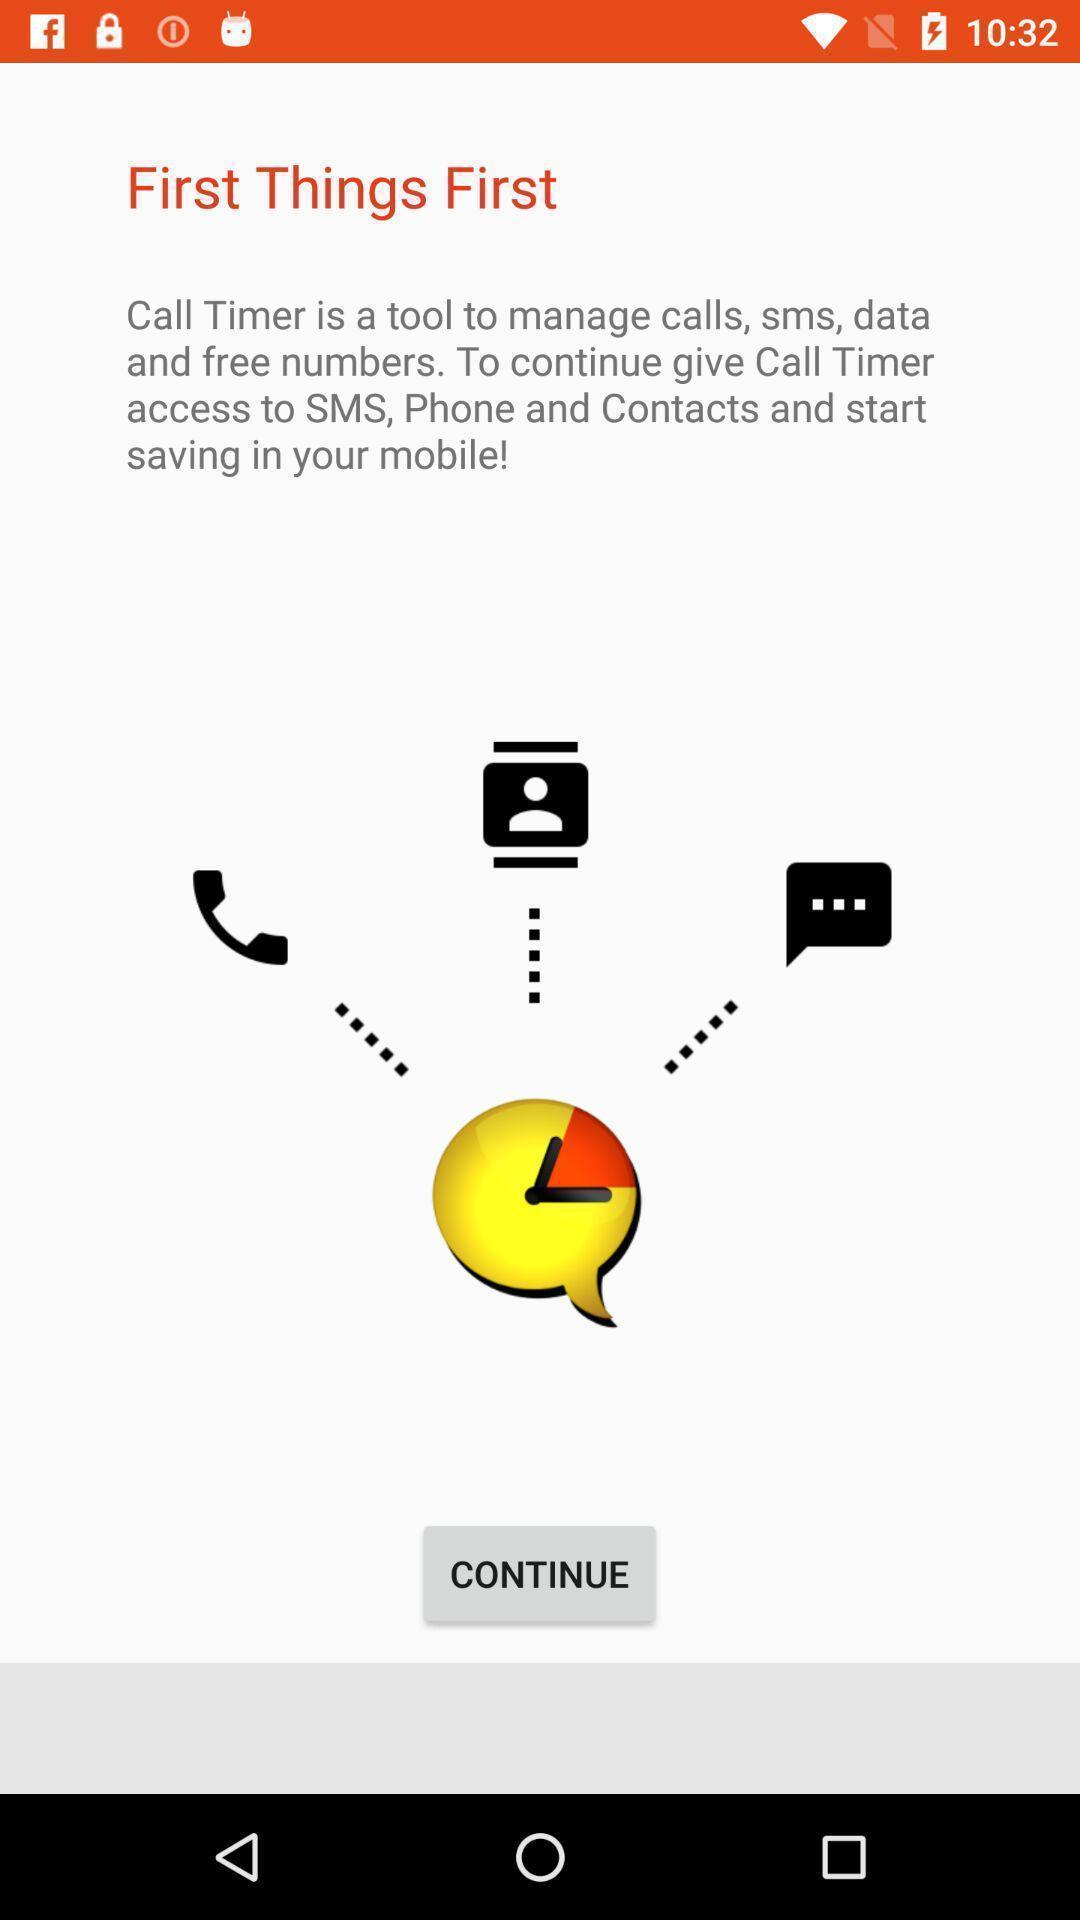What is the overall content of this screenshot? Welcome page for a calls managing app. 